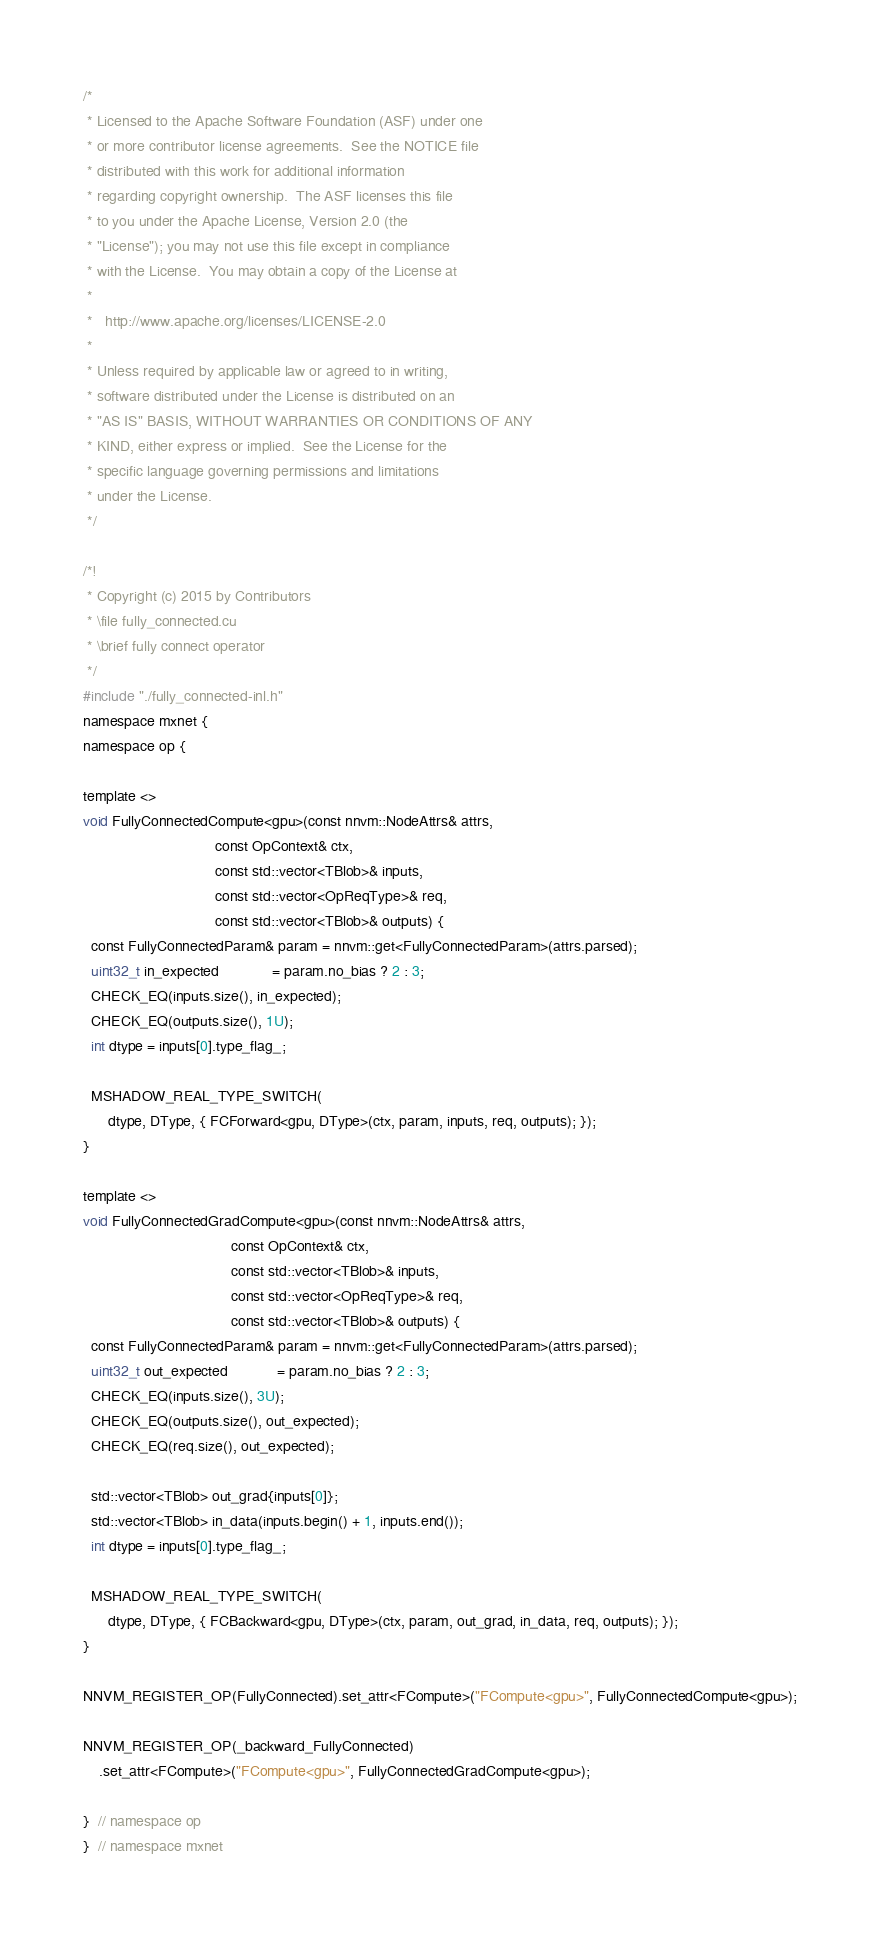<code> <loc_0><loc_0><loc_500><loc_500><_Cuda_>/*
 * Licensed to the Apache Software Foundation (ASF) under one
 * or more contributor license agreements.  See the NOTICE file
 * distributed with this work for additional information
 * regarding copyright ownership.  The ASF licenses this file
 * to you under the Apache License, Version 2.0 (the
 * "License"); you may not use this file except in compliance
 * with the License.  You may obtain a copy of the License at
 *
 *   http://www.apache.org/licenses/LICENSE-2.0
 *
 * Unless required by applicable law or agreed to in writing,
 * software distributed under the License is distributed on an
 * "AS IS" BASIS, WITHOUT WARRANTIES OR CONDITIONS OF ANY
 * KIND, either express or implied.  See the License for the
 * specific language governing permissions and limitations
 * under the License.
 */

/*!
 * Copyright (c) 2015 by Contributors
 * \file fully_connected.cu
 * \brief fully connect operator
 */
#include "./fully_connected-inl.h"
namespace mxnet {
namespace op {

template <>
void FullyConnectedCompute<gpu>(const nnvm::NodeAttrs& attrs,
                                const OpContext& ctx,
                                const std::vector<TBlob>& inputs,
                                const std::vector<OpReqType>& req,
                                const std::vector<TBlob>& outputs) {
  const FullyConnectedParam& param = nnvm::get<FullyConnectedParam>(attrs.parsed);
  uint32_t in_expected             = param.no_bias ? 2 : 3;
  CHECK_EQ(inputs.size(), in_expected);
  CHECK_EQ(outputs.size(), 1U);
  int dtype = inputs[0].type_flag_;

  MSHADOW_REAL_TYPE_SWITCH(
      dtype, DType, { FCForward<gpu, DType>(ctx, param, inputs, req, outputs); });
}

template <>
void FullyConnectedGradCompute<gpu>(const nnvm::NodeAttrs& attrs,
                                    const OpContext& ctx,
                                    const std::vector<TBlob>& inputs,
                                    const std::vector<OpReqType>& req,
                                    const std::vector<TBlob>& outputs) {
  const FullyConnectedParam& param = nnvm::get<FullyConnectedParam>(attrs.parsed);
  uint32_t out_expected            = param.no_bias ? 2 : 3;
  CHECK_EQ(inputs.size(), 3U);
  CHECK_EQ(outputs.size(), out_expected);
  CHECK_EQ(req.size(), out_expected);

  std::vector<TBlob> out_grad{inputs[0]};
  std::vector<TBlob> in_data(inputs.begin() + 1, inputs.end());
  int dtype = inputs[0].type_flag_;

  MSHADOW_REAL_TYPE_SWITCH(
      dtype, DType, { FCBackward<gpu, DType>(ctx, param, out_grad, in_data, req, outputs); });
}

NNVM_REGISTER_OP(FullyConnected).set_attr<FCompute>("FCompute<gpu>", FullyConnectedCompute<gpu>);

NNVM_REGISTER_OP(_backward_FullyConnected)
    .set_attr<FCompute>("FCompute<gpu>", FullyConnectedGradCompute<gpu>);

}  // namespace op
}  // namespace mxnet
</code> 